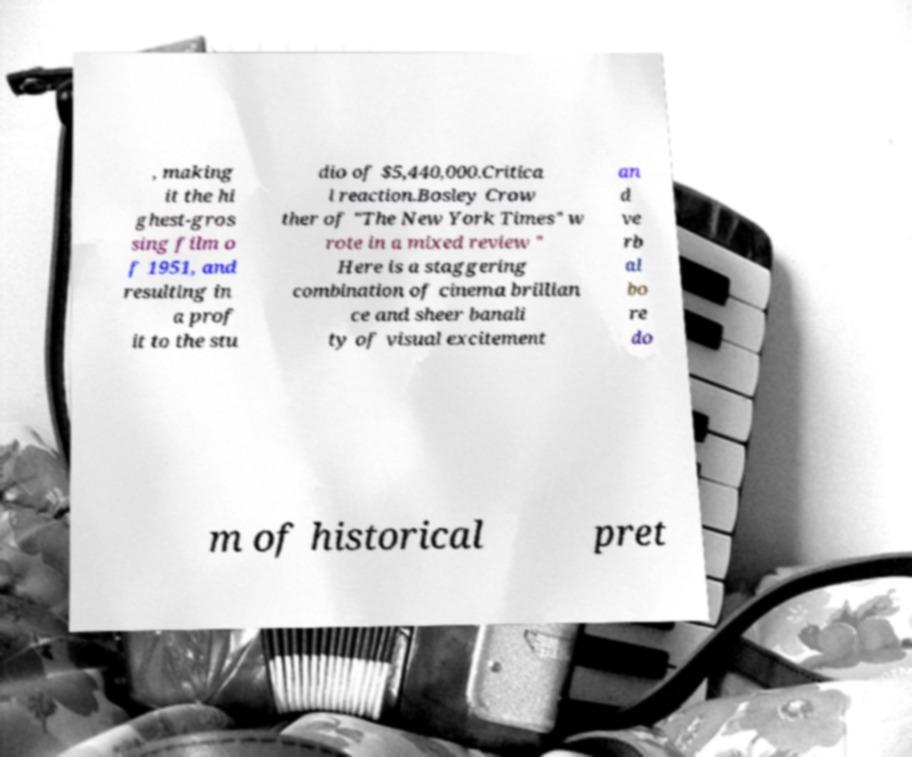Please identify and transcribe the text found in this image. , making it the hi ghest-gros sing film o f 1951, and resulting in a prof it to the stu dio of $5,440,000.Critica l reaction.Bosley Crow ther of "The New York Times" w rote in a mixed review " Here is a staggering combination of cinema brillian ce and sheer banali ty of visual excitement an d ve rb al bo re do m of historical pret 